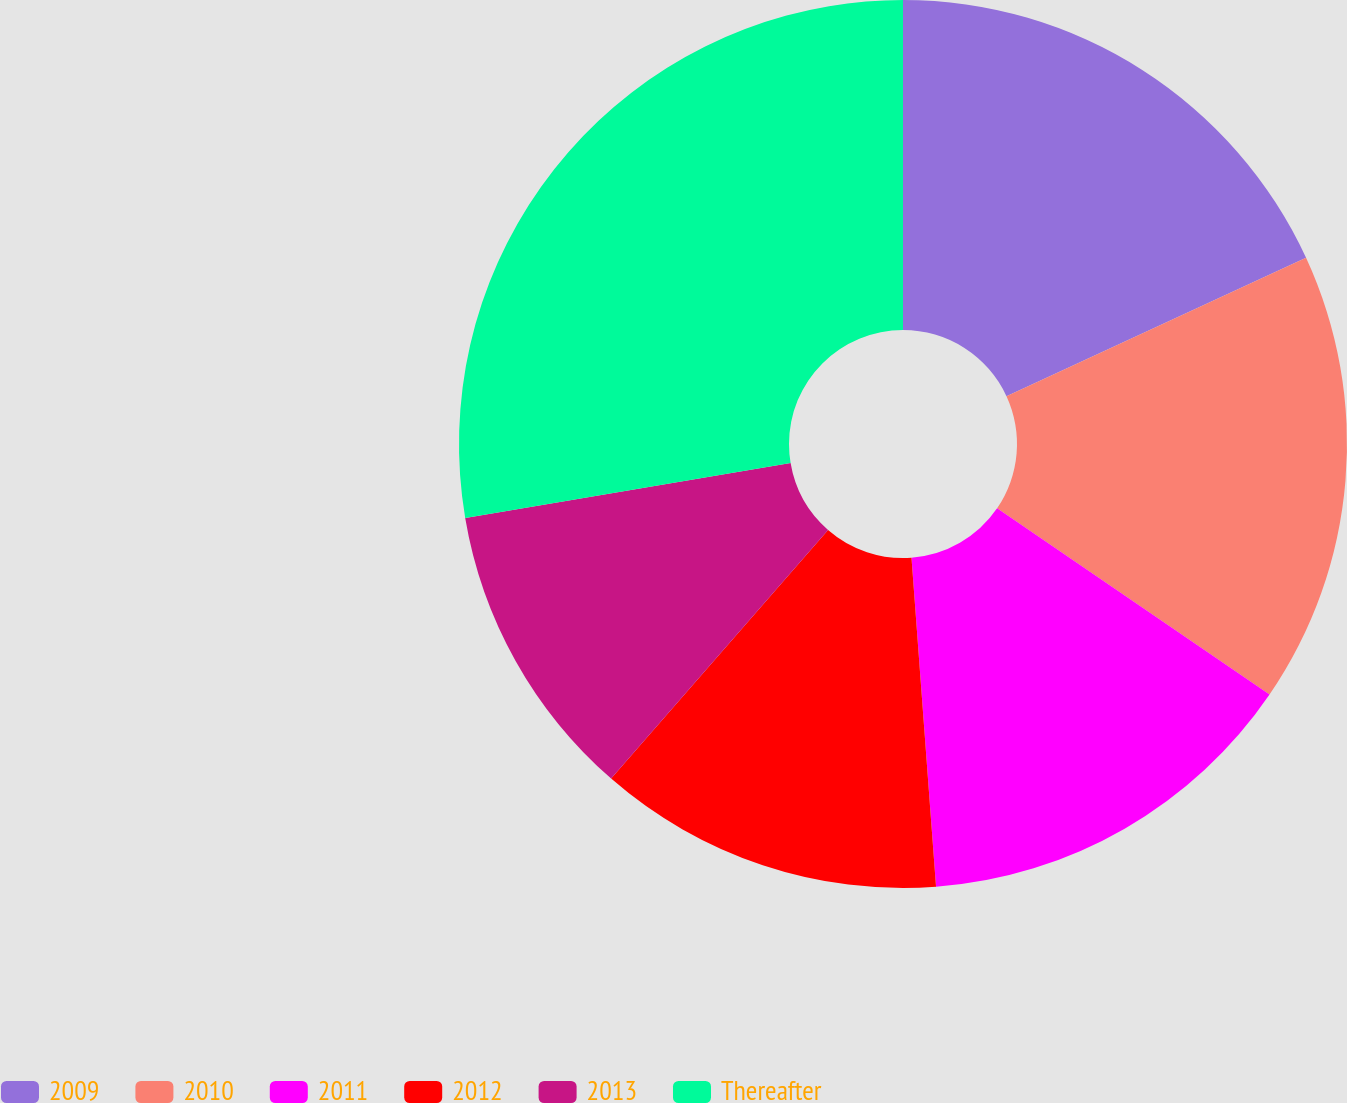Convert chart. <chart><loc_0><loc_0><loc_500><loc_500><pie_chart><fcel>2009<fcel>2010<fcel>2011<fcel>2012<fcel>2013<fcel>Thereafter<nl><fcel>18.11%<fcel>16.43%<fcel>14.27%<fcel>12.6%<fcel>10.92%<fcel>27.66%<nl></chart> 